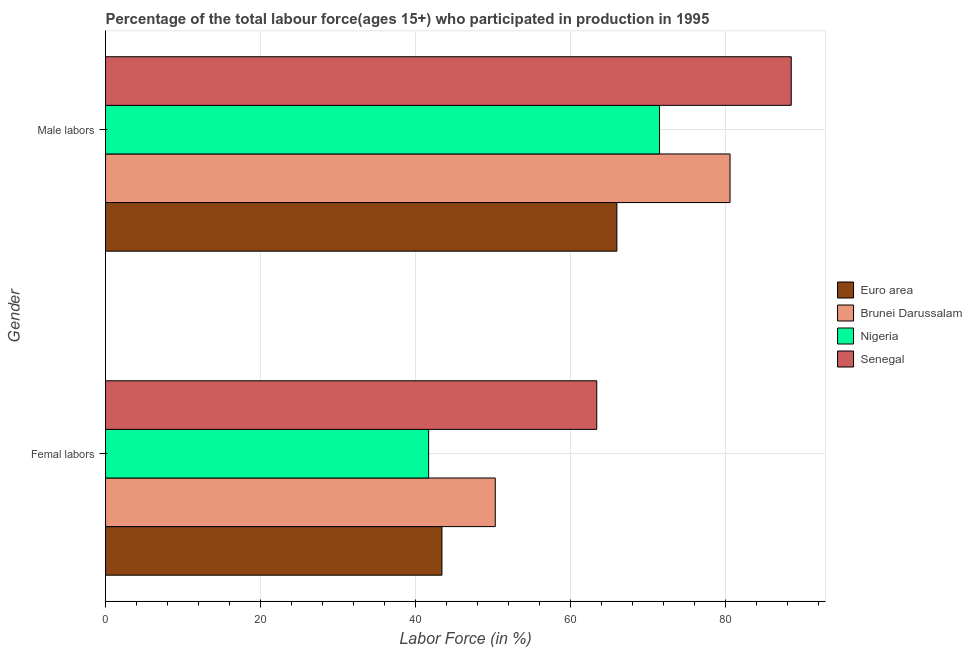Are the number of bars on each tick of the Y-axis equal?
Your answer should be very brief. Yes. How many bars are there on the 1st tick from the top?
Your response must be concise. 4. What is the label of the 2nd group of bars from the top?
Keep it short and to the point. Femal labors. What is the percentage of male labour force in Brunei Darussalam?
Your response must be concise. 80.6. Across all countries, what is the maximum percentage of female labor force?
Keep it short and to the point. 63.4. Across all countries, what is the minimum percentage of male labour force?
Your answer should be compact. 66. In which country was the percentage of female labor force maximum?
Provide a short and direct response. Senegal. What is the total percentage of female labor force in the graph?
Your answer should be compact. 198.82. What is the difference between the percentage of female labor force in Euro area and that in Senegal?
Provide a succinct answer. -19.98. What is the difference between the percentage of female labor force in Senegal and the percentage of male labour force in Nigeria?
Provide a succinct answer. -8.1. What is the average percentage of female labor force per country?
Your response must be concise. 49.7. What is the difference between the percentage of male labour force and percentage of female labor force in Brunei Darussalam?
Offer a terse response. 30.3. In how many countries, is the percentage of male labour force greater than 48 %?
Offer a terse response. 4. What is the ratio of the percentage of male labour force in Nigeria to that in Brunei Darussalam?
Your response must be concise. 0.89. In how many countries, is the percentage of female labor force greater than the average percentage of female labor force taken over all countries?
Provide a short and direct response. 2. What does the 1st bar from the top in Femal labors represents?
Ensure brevity in your answer.  Senegal. What does the 1st bar from the bottom in Femal labors represents?
Your response must be concise. Euro area. How many bars are there?
Ensure brevity in your answer.  8. Are all the bars in the graph horizontal?
Keep it short and to the point. Yes. How many countries are there in the graph?
Offer a terse response. 4. What is the difference between two consecutive major ticks on the X-axis?
Ensure brevity in your answer.  20. Does the graph contain any zero values?
Make the answer very short. No. Does the graph contain grids?
Keep it short and to the point. Yes. Where does the legend appear in the graph?
Make the answer very short. Center right. How are the legend labels stacked?
Provide a short and direct response. Vertical. What is the title of the graph?
Provide a succinct answer. Percentage of the total labour force(ages 15+) who participated in production in 1995. What is the label or title of the Y-axis?
Offer a very short reply. Gender. What is the Labor Force (in %) of Euro area in Femal labors?
Keep it short and to the point. 43.42. What is the Labor Force (in %) in Brunei Darussalam in Femal labors?
Provide a succinct answer. 50.3. What is the Labor Force (in %) in Nigeria in Femal labors?
Make the answer very short. 41.7. What is the Labor Force (in %) in Senegal in Femal labors?
Provide a succinct answer. 63.4. What is the Labor Force (in %) in Euro area in Male labors?
Ensure brevity in your answer.  66. What is the Labor Force (in %) in Brunei Darussalam in Male labors?
Your answer should be compact. 80.6. What is the Labor Force (in %) in Nigeria in Male labors?
Provide a short and direct response. 71.5. What is the Labor Force (in %) in Senegal in Male labors?
Keep it short and to the point. 88.5. Across all Gender, what is the maximum Labor Force (in %) in Euro area?
Make the answer very short. 66. Across all Gender, what is the maximum Labor Force (in %) of Brunei Darussalam?
Your answer should be compact. 80.6. Across all Gender, what is the maximum Labor Force (in %) in Nigeria?
Make the answer very short. 71.5. Across all Gender, what is the maximum Labor Force (in %) of Senegal?
Your response must be concise. 88.5. Across all Gender, what is the minimum Labor Force (in %) in Euro area?
Provide a short and direct response. 43.42. Across all Gender, what is the minimum Labor Force (in %) of Brunei Darussalam?
Make the answer very short. 50.3. Across all Gender, what is the minimum Labor Force (in %) of Nigeria?
Offer a very short reply. 41.7. Across all Gender, what is the minimum Labor Force (in %) of Senegal?
Offer a very short reply. 63.4. What is the total Labor Force (in %) of Euro area in the graph?
Keep it short and to the point. 109.42. What is the total Labor Force (in %) in Brunei Darussalam in the graph?
Provide a short and direct response. 130.9. What is the total Labor Force (in %) in Nigeria in the graph?
Provide a succinct answer. 113.2. What is the total Labor Force (in %) of Senegal in the graph?
Give a very brief answer. 151.9. What is the difference between the Labor Force (in %) in Euro area in Femal labors and that in Male labors?
Your answer should be very brief. -22.58. What is the difference between the Labor Force (in %) in Brunei Darussalam in Femal labors and that in Male labors?
Keep it short and to the point. -30.3. What is the difference between the Labor Force (in %) in Nigeria in Femal labors and that in Male labors?
Your response must be concise. -29.8. What is the difference between the Labor Force (in %) of Senegal in Femal labors and that in Male labors?
Ensure brevity in your answer.  -25.1. What is the difference between the Labor Force (in %) in Euro area in Femal labors and the Labor Force (in %) in Brunei Darussalam in Male labors?
Provide a succinct answer. -37.18. What is the difference between the Labor Force (in %) of Euro area in Femal labors and the Labor Force (in %) of Nigeria in Male labors?
Provide a short and direct response. -28.08. What is the difference between the Labor Force (in %) of Euro area in Femal labors and the Labor Force (in %) of Senegal in Male labors?
Provide a succinct answer. -45.08. What is the difference between the Labor Force (in %) of Brunei Darussalam in Femal labors and the Labor Force (in %) of Nigeria in Male labors?
Offer a terse response. -21.2. What is the difference between the Labor Force (in %) of Brunei Darussalam in Femal labors and the Labor Force (in %) of Senegal in Male labors?
Your response must be concise. -38.2. What is the difference between the Labor Force (in %) of Nigeria in Femal labors and the Labor Force (in %) of Senegal in Male labors?
Your answer should be very brief. -46.8. What is the average Labor Force (in %) of Euro area per Gender?
Provide a short and direct response. 54.71. What is the average Labor Force (in %) in Brunei Darussalam per Gender?
Ensure brevity in your answer.  65.45. What is the average Labor Force (in %) in Nigeria per Gender?
Your answer should be very brief. 56.6. What is the average Labor Force (in %) in Senegal per Gender?
Offer a very short reply. 75.95. What is the difference between the Labor Force (in %) in Euro area and Labor Force (in %) in Brunei Darussalam in Femal labors?
Provide a short and direct response. -6.88. What is the difference between the Labor Force (in %) of Euro area and Labor Force (in %) of Nigeria in Femal labors?
Your answer should be very brief. 1.72. What is the difference between the Labor Force (in %) in Euro area and Labor Force (in %) in Senegal in Femal labors?
Provide a short and direct response. -19.98. What is the difference between the Labor Force (in %) in Brunei Darussalam and Labor Force (in %) in Nigeria in Femal labors?
Your answer should be compact. 8.6. What is the difference between the Labor Force (in %) in Brunei Darussalam and Labor Force (in %) in Senegal in Femal labors?
Ensure brevity in your answer.  -13.1. What is the difference between the Labor Force (in %) of Nigeria and Labor Force (in %) of Senegal in Femal labors?
Provide a succinct answer. -21.7. What is the difference between the Labor Force (in %) of Euro area and Labor Force (in %) of Brunei Darussalam in Male labors?
Your answer should be compact. -14.6. What is the difference between the Labor Force (in %) in Euro area and Labor Force (in %) in Nigeria in Male labors?
Offer a terse response. -5.5. What is the difference between the Labor Force (in %) in Euro area and Labor Force (in %) in Senegal in Male labors?
Provide a succinct answer. -22.5. What is the difference between the Labor Force (in %) of Brunei Darussalam and Labor Force (in %) of Senegal in Male labors?
Provide a short and direct response. -7.9. What is the ratio of the Labor Force (in %) in Euro area in Femal labors to that in Male labors?
Keep it short and to the point. 0.66. What is the ratio of the Labor Force (in %) in Brunei Darussalam in Femal labors to that in Male labors?
Offer a very short reply. 0.62. What is the ratio of the Labor Force (in %) of Nigeria in Femal labors to that in Male labors?
Your response must be concise. 0.58. What is the ratio of the Labor Force (in %) in Senegal in Femal labors to that in Male labors?
Offer a very short reply. 0.72. What is the difference between the highest and the second highest Labor Force (in %) of Euro area?
Ensure brevity in your answer.  22.58. What is the difference between the highest and the second highest Labor Force (in %) of Brunei Darussalam?
Ensure brevity in your answer.  30.3. What is the difference between the highest and the second highest Labor Force (in %) of Nigeria?
Keep it short and to the point. 29.8. What is the difference between the highest and the second highest Labor Force (in %) in Senegal?
Offer a very short reply. 25.1. What is the difference between the highest and the lowest Labor Force (in %) in Euro area?
Your answer should be very brief. 22.58. What is the difference between the highest and the lowest Labor Force (in %) of Brunei Darussalam?
Provide a short and direct response. 30.3. What is the difference between the highest and the lowest Labor Force (in %) in Nigeria?
Offer a very short reply. 29.8. What is the difference between the highest and the lowest Labor Force (in %) of Senegal?
Provide a succinct answer. 25.1. 